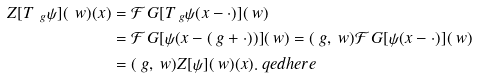Convert formula to latex. <formula><loc_0><loc_0><loc_500><loc_500>Z [ T _ { \ g } \psi ] ( \ w ) ( x ) & = \mathcal { F } _ { \ } G [ T _ { \ g } \psi ( x - \cdot ) ] ( \ w ) \\ & = \mathcal { F } _ { \ } G [ \psi ( x - ( \ g + \cdot ) ) ] ( \ w ) = ( \ g , \ w ) \mathcal { F } _ { \ } G [ \psi ( x - \cdot ) ] ( \ w ) \\ & = ( \ g , \ w ) Z [ \psi ] ( \ w ) ( x ) . \ q e d h e r e</formula> 